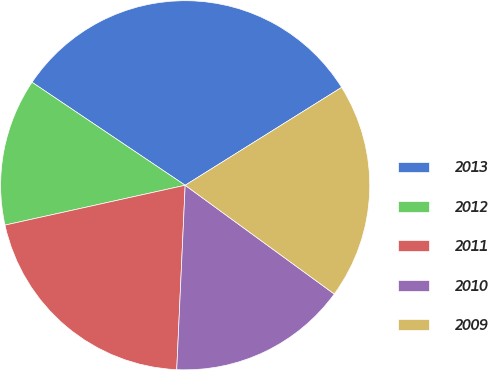Convert chart. <chart><loc_0><loc_0><loc_500><loc_500><pie_chart><fcel>2013<fcel>2012<fcel>2011<fcel>2010<fcel>2009<nl><fcel>31.68%<fcel>12.89%<fcel>20.81%<fcel>15.7%<fcel>18.93%<nl></chart> 